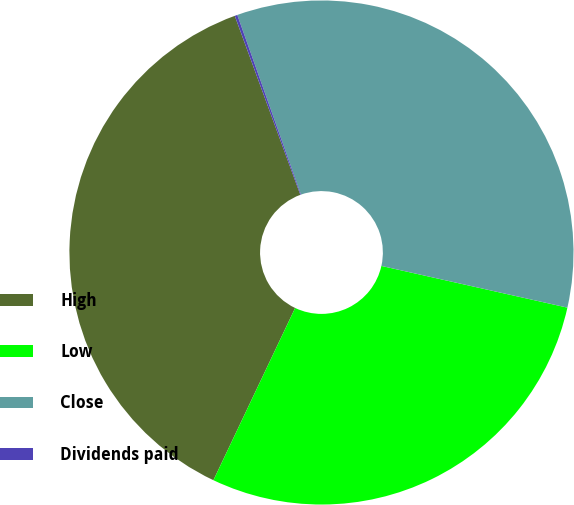Convert chart. <chart><loc_0><loc_0><loc_500><loc_500><pie_chart><fcel>High<fcel>Low<fcel>Close<fcel>Dividends paid<nl><fcel>37.36%<fcel>28.54%<fcel>33.93%<fcel>0.17%<nl></chart> 